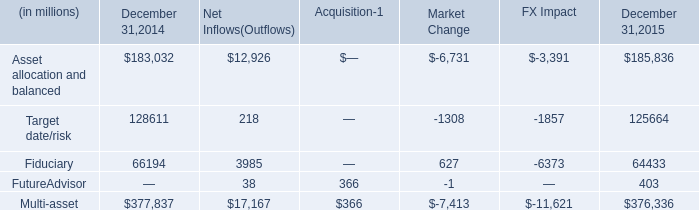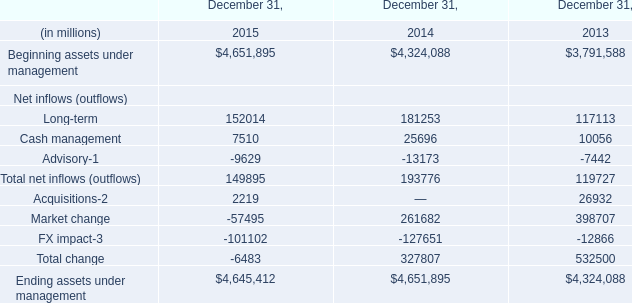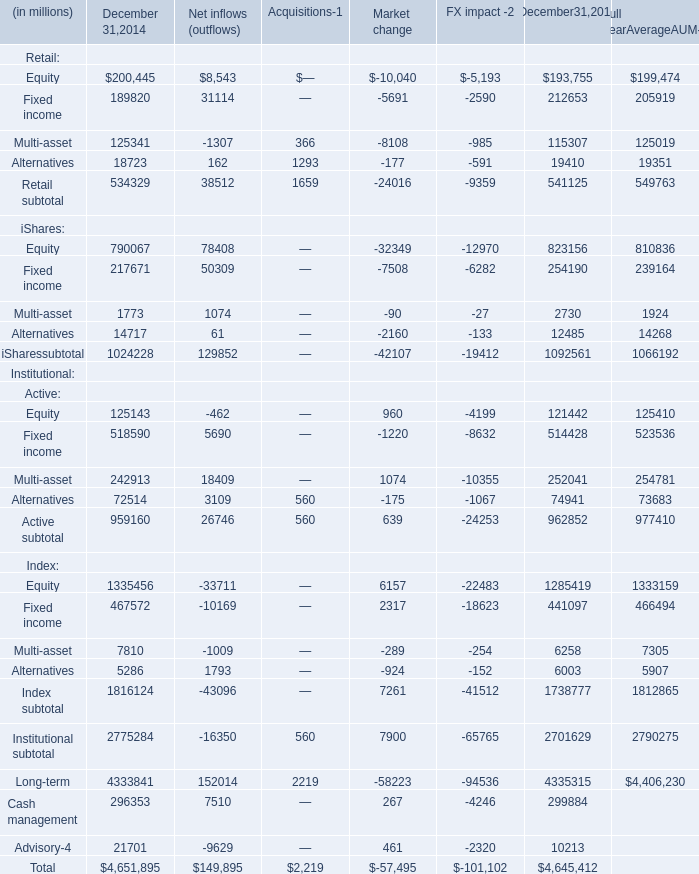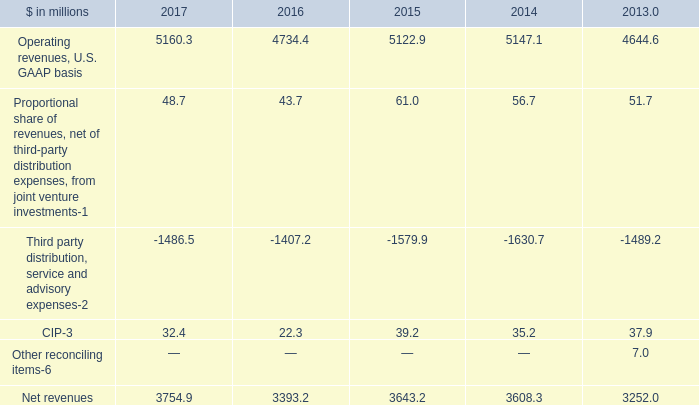What's the current growth rate of Beginning assets under management? 
Computations: ((4651895 - 4324088) / 4324088)
Answer: 0.07581. 